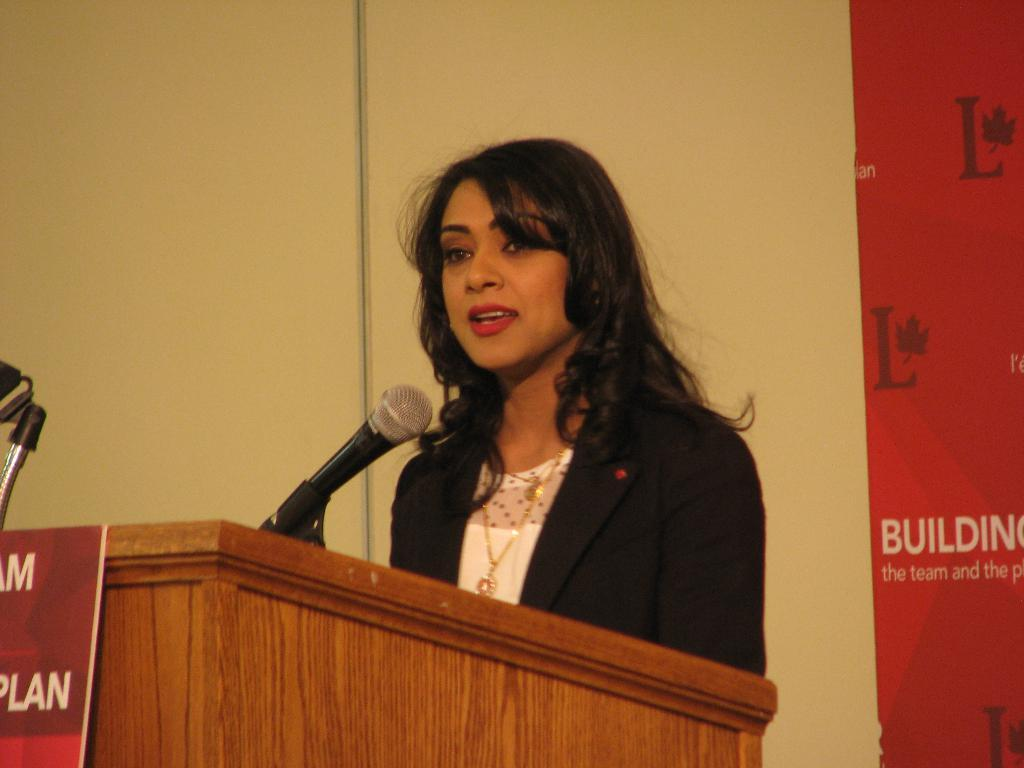What is the lady in the image doing? The lady is standing in the image. What is in front of the lady? There is a podium in front of the lady. What is placed on the podium? A microphone is placed on the podium. What can be seen in the background of the image? There is a wall and a board in the background of the image. How many tramps are visible in the image? There are no tramps present in the image. What type of jellyfish can be seen swimming in the background of the image? There are no jellyfish present in the image; it features a lady standing near a podium with a microphone. 